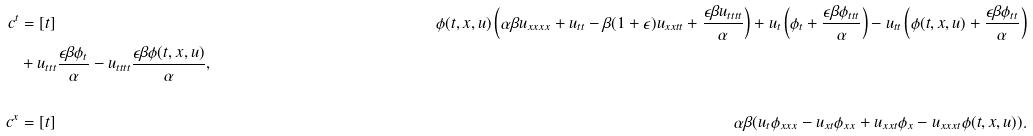Convert formula to latex. <formula><loc_0><loc_0><loc_500><loc_500>c ^ { t } & = [ t ] & \phi ( t , x , u ) \left ( \alpha \beta u _ { x x x x } + u _ { t t } - \beta ( 1 + \epsilon ) u _ { x x t t } + \frac { \epsilon \beta u _ { t t t t } } { \alpha } \right ) + u _ { t } \left ( \phi _ { t } + \frac { \epsilon \beta \phi _ { t t t } } { \alpha } \right ) - u _ { t t } \left ( \phi ( t , x , u ) + \frac { \epsilon \beta \phi _ { t t } } { \alpha } \right ) \\ & + u _ { t t t } \frac { \epsilon \beta \phi _ { t } } { \alpha } - u _ { t t t t } \frac { \epsilon \beta \phi ( t , x , u ) } { \alpha } , \\ \\ c ^ { x } & = [ t ] & \alpha \beta ( u _ { t } \phi _ { x x x } - u _ { x t } \phi _ { x x } + u _ { x x t } \phi _ { x } - u _ { x x x t } \phi ( t , x , u ) ) . \\ \\</formula> 